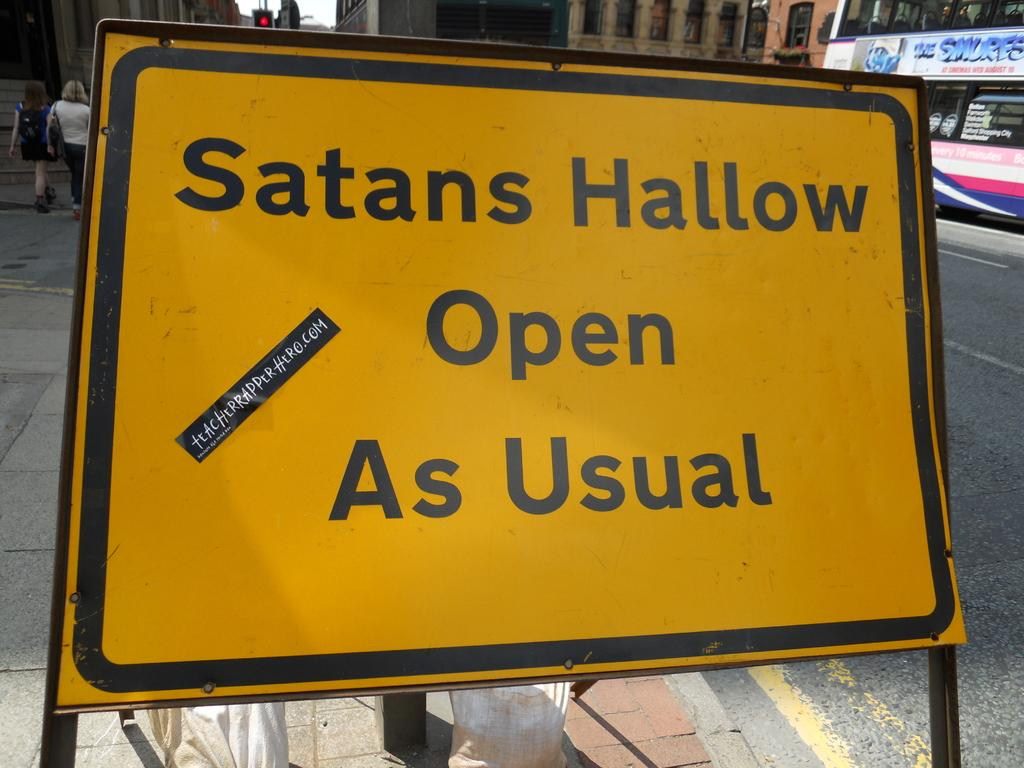<image>
Provide a brief description of the given image. A yellow and black rectangular sign says "Satans Hallow Open As Usual". 